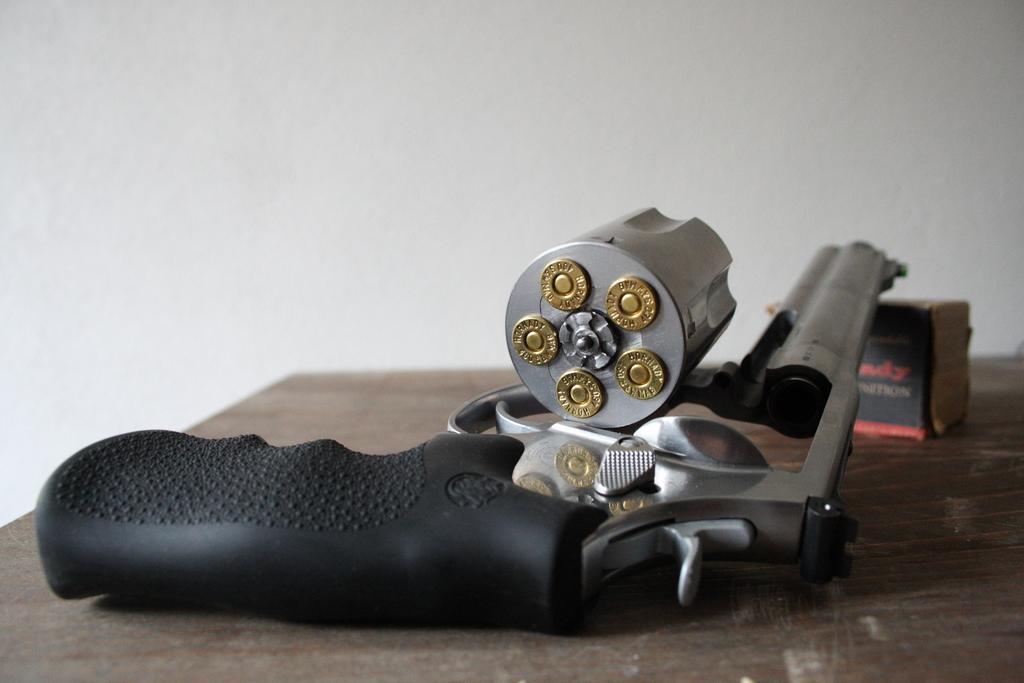What type of weapon is present in the image? There is a gun with bullets in the image. What other object can be seen in the image? There is a box in the image. Where are the gun and box located? The gun and box are placed on a table. What is visible in the background of the image? There is a wall in the background of the image. Can you tell me how many cacti are growing on the table in the image? There are no cacti present in the image; the objects on the table are a gun with bullets and a box. What type of animal is the father holding in the image? There is no father or animal present in the image; it only features a gun with bullets, a box, and a table. 